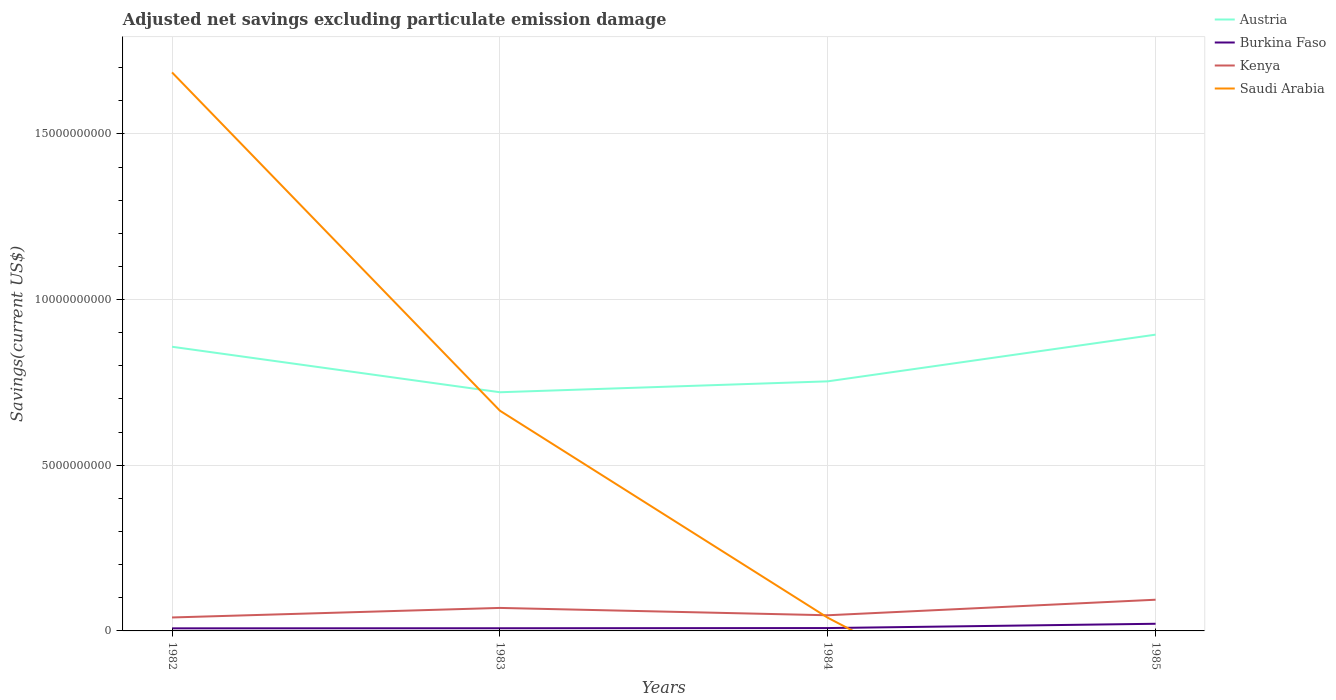What is the total adjusted net savings in Austria in the graph?
Your answer should be compact. -3.66e+08. What is the difference between the highest and the second highest adjusted net savings in Austria?
Provide a succinct answer. 1.74e+09. Is the adjusted net savings in Austria strictly greater than the adjusted net savings in Kenya over the years?
Offer a very short reply. No. How many lines are there?
Give a very brief answer. 4. What is the difference between two consecutive major ticks on the Y-axis?
Make the answer very short. 5.00e+09. How many legend labels are there?
Offer a terse response. 4. What is the title of the graph?
Your answer should be very brief. Adjusted net savings excluding particulate emission damage. What is the label or title of the X-axis?
Your answer should be compact. Years. What is the label or title of the Y-axis?
Keep it short and to the point. Savings(current US$). What is the Savings(current US$) of Austria in 1982?
Provide a short and direct response. 8.58e+09. What is the Savings(current US$) in Burkina Faso in 1982?
Give a very brief answer. 7.76e+07. What is the Savings(current US$) in Kenya in 1982?
Offer a very short reply. 4.06e+08. What is the Savings(current US$) in Saudi Arabia in 1982?
Provide a short and direct response. 1.69e+1. What is the Savings(current US$) in Austria in 1983?
Ensure brevity in your answer.  7.20e+09. What is the Savings(current US$) in Burkina Faso in 1983?
Give a very brief answer. 8.07e+07. What is the Savings(current US$) in Kenya in 1983?
Your answer should be compact. 6.94e+08. What is the Savings(current US$) in Saudi Arabia in 1983?
Your answer should be compact. 6.65e+09. What is the Savings(current US$) in Austria in 1984?
Make the answer very short. 7.53e+09. What is the Savings(current US$) in Burkina Faso in 1984?
Offer a terse response. 8.61e+07. What is the Savings(current US$) of Kenya in 1984?
Offer a terse response. 4.73e+08. What is the Savings(current US$) of Saudi Arabia in 1984?
Your response must be concise. 3.98e+08. What is the Savings(current US$) in Austria in 1985?
Make the answer very short. 8.94e+09. What is the Savings(current US$) of Burkina Faso in 1985?
Offer a very short reply. 2.16e+08. What is the Savings(current US$) of Kenya in 1985?
Keep it short and to the point. 9.42e+08. What is the Savings(current US$) in Saudi Arabia in 1985?
Offer a terse response. 0. Across all years, what is the maximum Savings(current US$) of Austria?
Ensure brevity in your answer.  8.94e+09. Across all years, what is the maximum Savings(current US$) in Burkina Faso?
Provide a succinct answer. 2.16e+08. Across all years, what is the maximum Savings(current US$) in Kenya?
Your answer should be compact. 9.42e+08. Across all years, what is the maximum Savings(current US$) of Saudi Arabia?
Your answer should be very brief. 1.69e+1. Across all years, what is the minimum Savings(current US$) of Austria?
Your answer should be very brief. 7.20e+09. Across all years, what is the minimum Savings(current US$) in Burkina Faso?
Your answer should be very brief. 7.76e+07. Across all years, what is the minimum Savings(current US$) in Kenya?
Make the answer very short. 4.06e+08. Across all years, what is the minimum Savings(current US$) in Saudi Arabia?
Your response must be concise. 0. What is the total Savings(current US$) in Austria in the graph?
Ensure brevity in your answer.  3.23e+1. What is the total Savings(current US$) of Burkina Faso in the graph?
Keep it short and to the point. 4.60e+08. What is the total Savings(current US$) in Kenya in the graph?
Provide a short and direct response. 2.51e+09. What is the total Savings(current US$) of Saudi Arabia in the graph?
Offer a terse response. 2.39e+1. What is the difference between the Savings(current US$) in Austria in 1982 and that in 1983?
Your answer should be very brief. 1.37e+09. What is the difference between the Savings(current US$) of Burkina Faso in 1982 and that in 1983?
Your answer should be very brief. -3.03e+06. What is the difference between the Savings(current US$) of Kenya in 1982 and that in 1983?
Offer a very short reply. -2.88e+08. What is the difference between the Savings(current US$) of Saudi Arabia in 1982 and that in 1983?
Offer a terse response. 1.02e+1. What is the difference between the Savings(current US$) of Austria in 1982 and that in 1984?
Provide a succinct answer. 1.04e+09. What is the difference between the Savings(current US$) in Burkina Faso in 1982 and that in 1984?
Your answer should be compact. -8.47e+06. What is the difference between the Savings(current US$) of Kenya in 1982 and that in 1984?
Offer a very short reply. -6.65e+07. What is the difference between the Savings(current US$) of Saudi Arabia in 1982 and that in 1984?
Provide a succinct answer. 1.65e+1. What is the difference between the Savings(current US$) in Austria in 1982 and that in 1985?
Keep it short and to the point. -3.66e+08. What is the difference between the Savings(current US$) of Burkina Faso in 1982 and that in 1985?
Your answer should be very brief. -1.38e+08. What is the difference between the Savings(current US$) in Kenya in 1982 and that in 1985?
Give a very brief answer. -5.36e+08. What is the difference between the Savings(current US$) in Austria in 1983 and that in 1984?
Give a very brief answer. -3.29e+08. What is the difference between the Savings(current US$) in Burkina Faso in 1983 and that in 1984?
Make the answer very short. -5.44e+06. What is the difference between the Savings(current US$) of Kenya in 1983 and that in 1984?
Provide a succinct answer. 2.21e+08. What is the difference between the Savings(current US$) of Saudi Arabia in 1983 and that in 1984?
Provide a succinct answer. 6.25e+09. What is the difference between the Savings(current US$) of Austria in 1983 and that in 1985?
Keep it short and to the point. -1.74e+09. What is the difference between the Savings(current US$) in Burkina Faso in 1983 and that in 1985?
Ensure brevity in your answer.  -1.35e+08. What is the difference between the Savings(current US$) of Kenya in 1983 and that in 1985?
Provide a short and direct response. -2.48e+08. What is the difference between the Savings(current US$) in Austria in 1984 and that in 1985?
Your response must be concise. -1.41e+09. What is the difference between the Savings(current US$) of Burkina Faso in 1984 and that in 1985?
Your answer should be very brief. -1.30e+08. What is the difference between the Savings(current US$) in Kenya in 1984 and that in 1985?
Your answer should be compact. -4.69e+08. What is the difference between the Savings(current US$) in Austria in 1982 and the Savings(current US$) in Burkina Faso in 1983?
Give a very brief answer. 8.50e+09. What is the difference between the Savings(current US$) in Austria in 1982 and the Savings(current US$) in Kenya in 1983?
Give a very brief answer. 7.88e+09. What is the difference between the Savings(current US$) of Austria in 1982 and the Savings(current US$) of Saudi Arabia in 1983?
Provide a succinct answer. 1.93e+09. What is the difference between the Savings(current US$) of Burkina Faso in 1982 and the Savings(current US$) of Kenya in 1983?
Your answer should be very brief. -6.16e+08. What is the difference between the Savings(current US$) of Burkina Faso in 1982 and the Savings(current US$) of Saudi Arabia in 1983?
Provide a short and direct response. -6.57e+09. What is the difference between the Savings(current US$) of Kenya in 1982 and the Savings(current US$) of Saudi Arabia in 1983?
Keep it short and to the point. -6.24e+09. What is the difference between the Savings(current US$) of Austria in 1982 and the Savings(current US$) of Burkina Faso in 1984?
Provide a short and direct response. 8.49e+09. What is the difference between the Savings(current US$) of Austria in 1982 and the Savings(current US$) of Kenya in 1984?
Your answer should be very brief. 8.10e+09. What is the difference between the Savings(current US$) of Austria in 1982 and the Savings(current US$) of Saudi Arabia in 1984?
Your response must be concise. 8.18e+09. What is the difference between the Savings(current US$) of Burkina Faso in 1982 and the Savings(current US$) of Kenya in 1984?
Offer a terse response. -3.95e+08. What is the difference between the Savings(current US$) in Burkina Faso in 1982 and the Savings(current US$) in Saudi Arabia in 1984?
Your answer should be very brief. -3.21e+08. What is the difference between the Savings(current US$) in Kenya in 1982 and the Savings(current US$) in Saudi Arabia in 1984?
Make the answer very short. 7.58e+06. What is the difference between the Savings(current US$) of Austria in 1982 and the Savings(current US$) of Burkina Faso in 1985?
Make the answer very short. 8.36e+09. What is the difference between the Savings(current US$) in Austria in 1982 and the Savings(current US$) in Kenya in 1985?
Your answer should be compact. 7.63e+09. What is the difference between the Savings(current US$) of Burkina Faso in 1982 and the Savings(current US$) of Kenya in 1985?
Keep it short and to the point. -8.64e+08. What is the difference between the Savings(current US$) in Austria in 1983 and the Savings(current US$) in Burkina Faso in 1984?
Your answer should be compact. 7.12e+09. What is the difference between the Savings(current US$) of Austria in 1983 and the Savings(current US$) of Kenya in 1984?
Keep it short and to the point. 6.73e+09. What is the difference between the Savings(current US$) in Austria in 1983 and the Savings(current US$) in Saudi Arabia in 1984?
Provide a short and direct response. 6.81e+09. What is the difference between the Savings(current US$) in Burkina Faso in 1983 and the Savings(current US$) in Kenya in 1984?
Give a very brief answer. -3.92e+08. What is the difference between the Savings(current US$) in Burkina Faso in 1983 and the Savings(current US$) in Saudi Arabia in 1984?
Offer a very short reply. -3.18e+08. What is the difference between the Savings(current US$) in Kenya in 1983 and the Savings(current US$) in Saudi Arabia in 1984?
Give a very brief answer. 2.96e+08. What is the difference between the Savings(current US$) of Austria in 1983 and the Savings(current US$) of Burkina Faso in 1985?
Provide a succinct answer. 6.99e+09. What is the difference between the Savings(current US$) of Austria in 1983 and the Savings(current US$) of Kenya in 1985?
Offer a terse response. 6.26e+09. What is the difference between the Savings(current US$) in Burkina Faso in 1983 and the Savings(current US$) in Kenya in 1985?
Ensure brevity in your answer.  -8.61e+08. What is the difference between the Savings(current US$) of Austria in 1984 and the Savings(current US$) of Burkina Faso in 1985?
Your response must be concise. 7.32e+09. What is the difference between the Savings(current US$) in Austria in 1984 and the Savings(current US$) in Kenya in 1985?
Give a very brief answer. 6.59e+09. What is the difference between the Savings(current US$) of Burkina Faso in 1984 and the Savings(current US$) of Kenya in 1985?
Keep it short and to the point. -8.56e+08. What is the average Savings(current US$) in Austria per year?
Keep it short and to the point. 8.06e+09. What is the average Savings(current US$) of Burkina Faso per year?
Your answer should be very brief. 1.15e+08. What is the average Savings(current US$) of Kenya per year?
Your answer should be very brief. 6.29e+08. What is the average Savings(current US$) in Saudi Arabia per year?
Make the answer very short. 5.98e+09. In the year 1982, what is the difference between the Savings(current US$) in Austria and Savings(current US$) in Burkina Faso?
Give a very brief answer. 8.50e+09. In the year 1982, what is the difference between the Savings(current US$) in Austria and Savings(current US$) in Kenya?
Provide a short and direct response. 8.17e+09. In the year 1982, what is the difference between the Savings(current US$) in Austria and Savings(current US$) in Saudi Arabia?
Provide a short and direct response. -8.28e+09. In the year 1982, what is the difference between the Savings(current US$) in Burkina Faso and Savings(current US$) in Kenya?
Give a very brief answer. -3.28e+08. In the year 1982, what is the difference between the Savings(current US$) of Burkina Faso and Savings(current US$) of Saudi Arabia?
Offer a terse response. -1.68e+1. In the year 1982, what is the difference between the Savings(current US$) of Kenya and Savings(current US$) of Saudi Arabia?
Offer a very short reply. -1.65e+1. In the year 1983, what is the difference between the Savings(current US$) in Austria and Savings(current US$) in Burkina Faso?
Offer a very short reply. 7.12e+09. In the year 1983, what is the difference between the Savings(current US$) of Austria and Savings(current US$) of Kenya?
Your response must be concise. 6.51e+09. In the year 1983, what is the difference between the Savings(current US$) in Austria and Savings(current US$) in Saudi Arabia?
Your response must be concise. 5.56e+08. In the year 1983, what is the difference between the Savings(current US$) of Burkina Faso and Savings(current US$) of Kenya?
Ensure brevity in your answer.  -6.13e+08. In the year 1983, what is the difference between the Savings(current US$) of Burkina Faso and Savings(current US$) of Saudi Arabia?
Your answer should be compact. -6.57e+09. In the year 1983, what is the difference between the Savings(current US$) of Kenya and Savings(current US$) of Saudi Arabia?
Your answer should be very brief. -5.95e+09. In the year 1984, what is the difference between the Savings(current US$) of Austria and Savings(current US$) of Burkina Faso?
Keep it short and to the point. 7.45e+09. In the year 1984, what is the difference between the Savings(current US$) of Austria and Savings(current US$) of Kenya?
Ensure brevity in your answer.  7.06e+09. In the year 1984, what is the difference between the Savings(current US$) in Austria and Savings(current US$) in Saudi Arabia?
Ensure brevity in your answer.  7.13e+09. In the year 1984, what is the difference between the Savings(current US$) of Burkina Faso and Savings(current US$) of Kenya?
Make the answer very short. -3.86e+08. In the year 1984, what is the difference between the Savings(current US$) in Burkina Faso and Savings(current US$) in Saudi Arabia?
Give a very brief answer. -3.12e+08. In the year 1984, what is the difference between the Savings(current US$) of Kenya and Savings(current US$) of Saudi Arabia?
Give a very brief answer. 7.40e+07. In the year 1985, what is the difference between the Savings(current US$) of Austria and Savings(current US$) of Burkina Faso?
Your answer should be very brief. 8.73e+09. In the year 1985, what is the difference between the Savings(current US$) of Austria and Savings(current US$) of Kenya?
Your response must be concise. 8.00e+09. In the year 1985, what is the difference between the Savings(current US$) of Burkina Faso and Savings(current US$) of Kenya?
Your response must be concise. -7.26e+08. What is the ratio of the Savings(current US$) in Austria in 1982 to that in 1983?
Provide a short and direct response. 1.19. What is the ratio of the Savings(current US$) of Burkina Faso in 1982 to that in 1983?
Provide a succinct answer. 0.96. What is the ratio of the Savings(current US$) in Kenya in 1982 to that in 1983?
Your answer should be compact. 0.59. What is the ratio of the Savings(current US$) in Saudi Arabia in 1982 to that in 1983?
Keep it short and to the point. 2.54. What is the ratio of the Savings(current US$) of Austria in 1982 to that in 1984?
Offer a terse response. 1.14. What is the ratio of the Savings(current US$) of Burkina Faso in 1982 to that in 1984?
Give a very brief answer. 0.9. What is the ratio of the Savings(current US$) of Kenya in 1982 to that in 1984?
Offer a very short reply. 0.86. What is the ratio of the Savings(current US$) in Saudi Arabia in 1982 to that in 1984?
Your answer should be very brief. 42.31. What is the ratio of the Savings(current US$) in Austria in 1982 to that in 1985?
Your answer should be compact. 0.96. What is the ratio of the Savings(current US$) in Burkina Faso in 1982 to that in 1985?
Your response must be concise. 0.36. What is the ratio of the Savings(current US$) in Kenya in 1982 to that in 1985?
Your response must be concise. 0.43. What is the ratio of the Savings(current US$) of Austria in 1983 to that in 1984?
Provide a succinct answer. 0.96. What is the ratio of the Savings(current US$) of Burkina Faso in 1983 to that in 1984?
Provide a succinct answer. 0.94. What is the ratio of the Savings(current US$) in Kenya in 1983 to that in 1984?
Ensure brevity in your answer.  1.47. What is the ratio of the Savings(current US$) of Saudi Arabia in 1983 to that in 1984?
Give a very brief answer. 16.68. What is the ratio of the Savings(current US$) in Austria in 1983 to that in 1985?
Make the answer very short. 0.81. What is the ratio of the Savings(current US$) in Burkina Faso in 1983 to that in 1985?
Ensure brevity in your answer.  0.37. What is the ratio of the Savings(current US$) of Kenya in 1983 to that in 1985?
Your answer should be very brief. 0.74. What is the ratio of the Savings(current US$) in Austria in 1984 to that in 1985?
Your response must be concise. 0.84. What is the ratio of the Savings(current US$) of Burkina Faso in 1984 to that in 1985?
Give a very brief answer. 0.4. What is the ratio of the Savings(current US$) of Kenya in 1984 to that in 1985?
Offer a terse response. 0.5. What is the difference between the highest and the second highest Savings(current US$) of Austria?
Your response must be concise. 3.66e+08. What is the difference between the highest and the second highest Savings(current US$) in Burkina Faso?
Provide a succinct answer. 1.30e+08. What is the difference between the highest and the second highest Savings(current US$) in Kenya?
Offer a terse response. 2.48e+08. What is the difference between the highest and the second highest Savings(current US$) in Saudi Arabia?
Provide a succinct answer. 1.02e+1. What is the difference between the highest and the lowest Savings(current US$) in Austria?
Ensure brevity in your answer.  1.74e+09. What is the difference between the highest and the lowest Savings(current US$) of Burkina Faso?
Make the answer very short. 1.38e+08. What is the difference between the highest and the lowest Savings(current US$) in Kenya?
Ensure brevity in your answer.  5.36e+08. What is the difference between the highest and the lowest Savings(current US$) of Saudi Arabia?
Provide a short and direct response. 1.69e+1. 